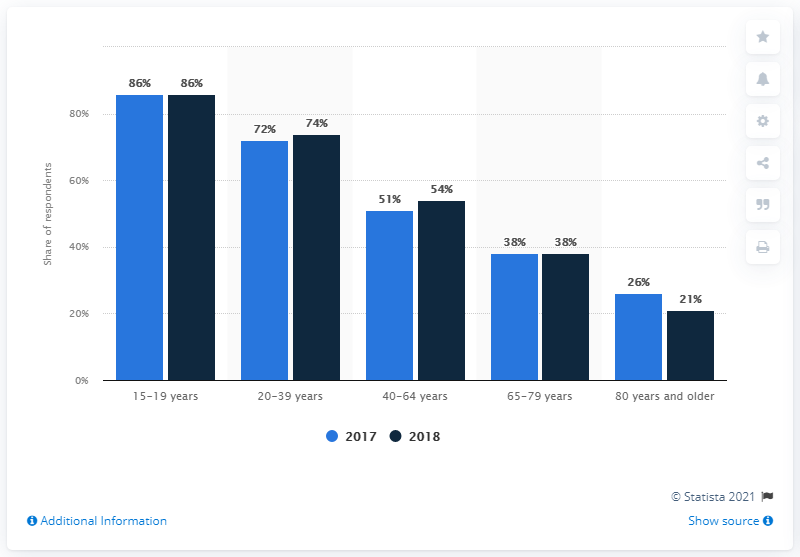Identify some key points in this picture. Approximately 47% of respondents aged 80 or older reported using YouTube. In 2018, 54% of respondents aged 40-64 years used YouTube. 